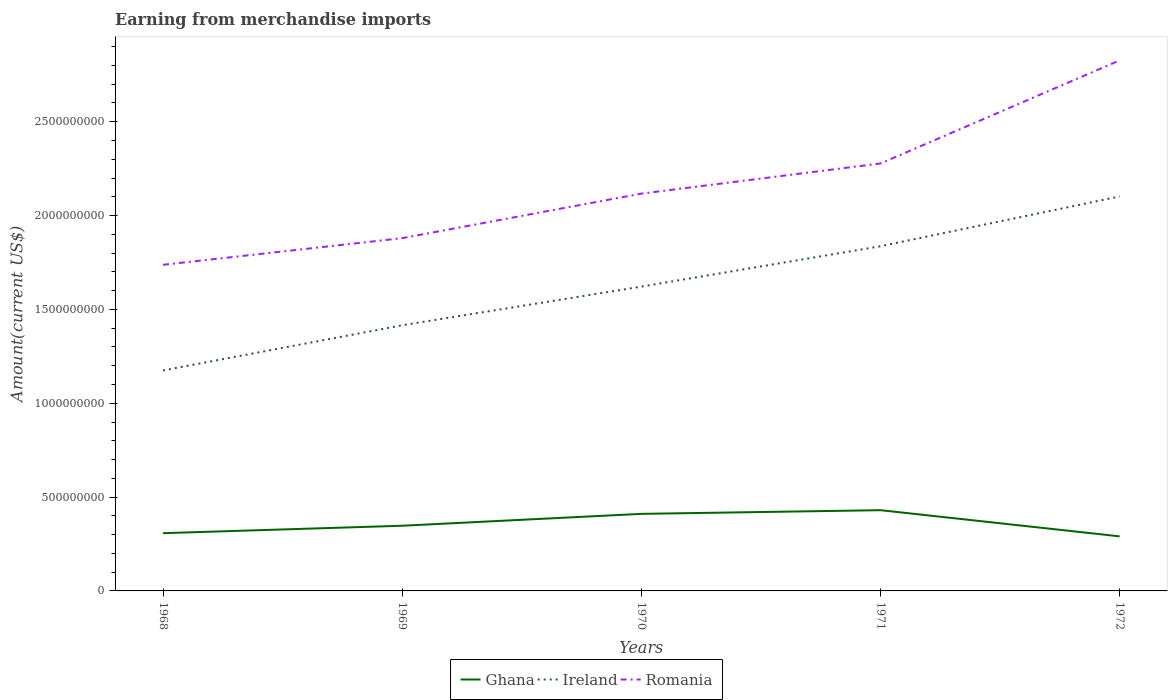Is the number of lines equal to the number of legend labels?
Your response must be concise. Yes. Across all years, what is the maximum amount earned from merchandise imports in Ghana?
Keep it short and to the point. 2.91e+08. In which year was the amount earned from merchandise imports in Romania maximum?
Provide a short and direct response. 1968. What is the total amount earned from merchandise imports in Ghana in the graph?
Offer a very short reply. -3.96e+07. What is the difference between the highest and the second highest amount earned from merchandise imports in Ghana?
Offer a very short reply. 1.39e+08. What is the difference between the highest and the lowest amount earned from merchandise imports in Ghana?
Your answer should be compact. 2. Is the amount earned from merchandise imports in Romania strictly greater than the amount earned from merchandise imports in Ghana over the years?
Ensure brevity in your answer.  No. How many lines are there?
Keep it short and to the point. 3. How many years are there in the graph?
Your answer should be compact. 5. What is the difference between two consecutive major ticks on the Y-axis?
Ensure brevity in your answer.  5.00e+08. Are the values on the major ticks of Y-axis written in scientific E-notation?
Offer a very short reply. No. Does the graph contain any zero values?
Your answer should be very brief. No. Does the graph contain grids?
Provide a succinct answer. No. Where does the legend appear in the graph?
Offer a terse response. Bottom center. How are the legend labels stacked?
Make the answer very short. Horizontal. What is the title of the graph?
Keep it short and to the point. Earning from merchandise imports. Does "Chile" appear as one of the legend labels in the graph?
Offer a terse response. No. What is the label or title of the Y-axis?
Offer a terse response. Amount(current US$). What is the Amount(current US$) in Ghana in 1968?
Your answer should be very brief. 3.08e+08. What is the Amount(current US$) of Ireland in 1968?
Give a very brief answer. 1.17e+09. What is the Amount(current US$) of Romania in 1968?
Your answer should be very brief. 1.74e+09. What is the Amount(current US$) in Ghana in 1969?
Provide a succinct answer. 3.47e+08. What is the Amount(current US$) in Ireland in 1969?
Give a very brief answer. 1.42e+09. What is the Amount(current US$) of Romania in 1969?
Your response must be concise. 1.88e+09. What is the Amount(current US$) of Ghana in 1970?
Your answer should be very brief. 4.11e+08. What is the Amount(current US$) of Ireland in 1970?
Give a very brief answer. 1.62e+09. What is the Amount(current US$) in Romania in 1970?
Ensure brevity in your answer.  2.12e+09. What is the Amount(current US$) of Ghana in 1971?
Your response must be concise. 4.30e+08. What is the Amount(current US$) of Ireland in 1971?
Offer a very short reply. 1.84e+09. What is the Amount(current US$) of Romania in 1971?
Provide a succinct answer. 2.28e+09. What is the Amount(current US$) of Ghana in 1972?
Your answer should be compact. 2.91e+08. What is the Amount(current US$) in Ireland in 1972?
Give a very brief answer. 2.10e+09. What is the Amount(current US$) of Romania in 1972?
Give a very brief answer. 2.83e+09. Across all years, what is the maximum Amount(current US$) of Ghana?
Offer a terse response. 4.30e+08. Across all years, what is the maximum Amount(current US$) in Ireland?
Give a very brief answer. 2.10e+09. Across all years, what is the maximum Amount(current US$) of Romania?
Your answer should be very brief. 2.83e+09. Across all years, what is the minimum Amount(current US$) in Ghana?
Your answer should be compact. 2.91e+08. Across all years, what is the minimum Amount(current US$) of Ireland?
Give a very brief answer. 1.17e+09. Across all years, what is the minimum Amount(current US$) of Romania?
Keep it short and to the point. 1.74e+09. What is the total Amount(current US$) of Ghana in the graph?
Your answer should be compact. 1.79e+09. What is the total Amount(current US$) of Ireland in the graph?
Your answer should be very brief. 8.15e+09. What is the total Amount(current US$) of Romania in the graph?
Offer a very short reply. 1.08e+1. What is the difference between the Amount(current US$) in Ghana in 1968 and that in 1969?
Make the answer very short. -3.96e+07. What is the difference between the Amount(current US$) in Ireland in 1968 and that in 1969?
Provide a succinct answer. -2.41e+08. What is the difference between the Amount(current US$) of Romania in 1968 and that in 1969?
Ensure brevity in your answer.  -1.42e+08. What is the difference between the Amount(current US$) of Ghana in 1968 and that in 1970?
Make the answer very short. -1.03e+08. What is the difference between the Amount(current US$) of Ireland in 1968 and that in 1970?
Keep it short and to the point. -4.47e+08. What is the difference between the Amount(current US$) of Romania in 1968 and that in 1970?
Provide a succinct answer. -3.79e+08. What is the difference between the Amount(current US$) of Ghana in 1968 and that in 1971?
Offer a very short reply. -1.22e+08. What is the difference between the Amount(current US$) in Ireland in 1968 and that in 1971?
Offer a terse response. -6.62e+08. What is the difference between the Amount(current US$) of Romania in 1968 and that in 1971?
Offer a terse response. -5.40e+08. What is the difference between the Amount(current US$) in Ghana in 1968 and that in 1972?
Provide a succinct answer. 1.70e+07. What is the difference between the Amount(current US$) in Ireland in 1968 and that in 1972?
Keep it short and to the point. -9.27e+08. What is the difference between the Amount(current US$) in Romania in 1968 and that in 1972?
Your answer should be very brief. -1.09e+09. What is the difference between the Amount(current US$) of Ghana in 1969 and that in 1970?
Ensure brevity in your answer.  -6.33e+07. What is the difference between the Amount(current US$) of Ireland in 1969 and that in 1970?
Your response must be concise. -2.06e+08. What is the difference between the Amount(current US$) in Romania in 1969 and that in 1970?
Provide a short and direct response. -2.37e+08. What is the difference between the Amount(current US$) in Ghana in 1969 and that in 1971?
Offer a very short reply. -8.29e+07. What is the difference between the Amount(current US$) in Ireland in 1969 and that in 1971?
Your response must be concise. -4.21e+08. What is the difference between the Amount(current US$) in Romania in 1969 and that in 1971?
Your response must be concise. -3.98e+08. What is the difference between the Amount(current US$) of Ghana in 1969 and that in 1972?
Provide a succinct answer. 5.66e+07. What is the difference between the Amount(current US$) in Ireland in 1969 and that in 1972?
Make the answer very short. -6.86e+08. What is the difference between the Amount(current US$) of Romania in 1969 and that in 1972?
Your response must be concise. -9.47e+08. What is the difference between the Amount(current US$) in Ghana in 1970 and that in 1971?
Make the answer very short. -1.96e+07. What is the difference between the Amount(current US$) in Ireland in 1970 and that in 1971?
Give a very brief answer. -2.15e+08. What is the difference between the Amount(current US$) of Romania in 1970 and that in 1971?
Provide a short and direct response. -1.61e+08. What is the difference between the Amount(current US$) in Ghana in 1970 and that in 1972?
Your answer should be very brief. 1.20e+08. What is the difference between the Amount(current US$) in Ireland in 1970 and that in 1972?
Provide a succinct answer. -4.80e+08. What is the difference between the Amount(current US$) in Romania in 1970 and that in 1972?
Provide a succinct answer. -7.10e+08. What is the difference between the Amount(current US$) of Ghana in 1971 and that in 1972?
Make the answer very short. 1.39e+08. What is the difference between the Amount(current US$) in Ireland in 1971 and that in 1972?
Keep it short and to the point. -2.65e+08. What is the difference between the Amount(current US$) of Romania in 1971 and that in 1972?
Your answer should be compact. -5.49e+08. What is the difference between the Amount(current US$) of Ghana in 1968 and the Amount(current US$) of Ireland in 1969?
Provide a succinct answer. -1.11e+09. What is the difference between the Amount(current US$) in Ghana in 1968 and the Amount(current US$) in Romania in 1969?
Your answer should be very brief. -1.57e+09. What is the difference between the Amount(current US$) in Ireland in 1968 and the Amount(current US$) in Romania in 1969?
Your answer should be very brief. -7.05e+08. What is the difference between the Amount(current US$) of Ghana in 1968 and the Amount(current US$) of Ireland in 1970?
Provide a short and direct response. -1.31e+09. What is the difference between the Amount(current US$) in Ghana in 1968 and the Amount(current US$) in Romania in 1970?
Your response must be concise. -1.81e+09. What is the difference between the Amount(current US$) in Ireland in 1968 and the Amount(current US$) in Romania in 1970?
Offer a very short reply. -9.42e+08. What is the difference between the Amount(current US$) of Ghana in 1968 and the Amount(current US$) of Ireland in 1971?
Your answer should be very brief. -1.53e+09. What is the difference between the Amount(current US$) of Ghana in 1968 and the Amount(current US$) of Romania in 1971?
Your answer should be very brief. -1.97e+09. What is the difference between the Amount(current US$) in Ireland in 1968 and the Amount(current US$) in Romania in 1971?
Provide a short and direct response. -1.10e+09. What is the difference between the Amount(current US$) in Ghana in 1968 and the Amount(current US$) in Ireland in 1972?
Your answer should be very brief. -1.79e+09. What is the difference between the Amount(current US$) in Ghana in 1968 and the Amount(current US$) in Romania in 1972?
Ensure brevity in your answer.  -2.52e+09. What is the difference between the Amount(current US$) of Ireland in 1968 and the Amount(current US$) of Romania in 1972?
Offer a terse response. -1.65e+09. What is the difference between the Amount(current US$) of Ghana in 1969 and the Amount(current US$) of Ireland in 1970?
Your response must be concise. -1.27e+09. What is the difference between the Amount(current US$) of Ghana in 1969 and the Amount(current US$) of Romania in 1970?
Your response must be concise. -1.77e+09. What is the difference between the Amount(current US$) in Ireland in 1969 and the Amount(current US$) in Romania in 1970?
Provide a succinct answer. -7.01e+08. What is the difference between the Amount(current US$) of Ghana in 1969 and the Amount(current US$) of Ireland in 1971?
Give a very brief answer. -1.49e+09. What is the difference between the Amount(current US$) in Ghana in 1969 and the Amount(current US$) in Romania in 1971?
Your answer should be compact. -1.93e+09. What is the difference between the Amount(current US$) in Ireland in 1969 and the Amount(current US$) in Romania in 1971?
Give a very brief answer. -8.62e+08. What is the difference between the Amount(current US$) of Ghana in 1969 and the Amount(current US$) of Ireland in 1972?
Ensure brevity in your answer.  -1.75e+09. What is the difference between the Amount(current US$) of Ghana in 1969 and the Amount(current US$) of Romania in 1972?
Your answer should be compact. -2.48e+09. What is the difference between the Amount(current US$) in Ireland in 1969 and the Amount(current US$) in Romania in 1972?
Give a very brief answer. -1.41e+09. What is the difference between the Amount(current US$) of Ghana in 1970 and the Amount(current US$) of Ireland in 1971?
Offer a very short reply. -1.43e+09. What is the difference between the Amount(current US$) of Ghana in 1970 and the Amount(current US$) of Romania in 1971?
Offer a very short reply. -1.87e+09. What is the difference between the Amount(current US$) of Ireland in 1970 and the Amount(current US$) of Romania in 1971?
Give a very brief answer. -6.56e+08. What is the difference between the Amount(current US$) of Ghana in 1970 and the Amount(current US$) of Ireland in 1972?
Offer a terse response. -1.69e+09. What is the difference between the Amount(current US$) of Ghana in 1970 and the Amount(current US$) of Romania in 1972?
Offer a very short reply. -2.42e+09. What is the difference between the Amount(current US$) in Ireland in 1970 and the Amount(current US$) in Romania in 1972?
Your answer should be very brief. -1.21e+09. What is the difference between the Amount(current US$) in Ghana in 1971 and the Amount(current US$) in Ireland in 1972?
Offer a terse response. -1.67e+09. What is the difference between the Amount(current US$) of Ghana in 1971 and the Amount(current US$) of Romania in 1972?
Your answer should be very brief. -2.40e+09. What is the difference between the Amount(current US$) of Ireland in 1971 and the Amount(current US$) of Romania in 1972?
Your answer should be compact. -9.90e+08. What is the average Amount(current US$) of Ghana per year?
Keep it short and to the point. 3.57e+08. What is the average Amount(current US$) in Ireland per year?
Provide a short and direct response. 1.63e+09. What is the average Amount(current US$) in Romania per year?
Make the answer very short. 2.17e+09. In the year 1968, what is the difference between the Amount(current US$) in Ghana and Amount(current US$) in Ireland?
Give a very brief answer. -8.67e+08. In the year 1968, what is the difference between the Amount(current US$) of Ghana and Amount(current US$) of Romania?
Offer a very short reply. -1.43e+09. In the year 1968, what is the difference between the Amount(current US$) in Ireland and Amount(current US$) in Romania?
Your answer should be compact. -5.63e+08. In the year 1969, what is the difference between the Amount(current US$) of Ghana and Amount(current US$) of Ireland?
Give a very brief answer. -1.07e+09. In the year 1969, what is the difference between the Amount(current US$) in Ghana and Amount(current US$) in Romania?
Offer a very short reply. -1.53e+09. In the year 1969, what is the difference between the Amount(current US$) in Ireland and Amount(current US$) in Romania?
Ensure brevity in your answer.  -4.64e+08. In the year 1970, what is the difference between the Amount(current US$) in Ghana and Amount(current US$) in Ireland?
Give a very brief answer. -1.21e+09. In the year 1970, what is the difference between the Amount(current US$) in Ghana and Amount(current US$) in Romania?
Provide a short and direct response. -1.71e+09. In the year 1970, what is the difference between the Amount(current US$) of Ireland and Amount(current US$) of Romania?
Offer a very short reply. -4.96e+08. In the year 1971, what is the difference between the Amount(current US$) of Ghana and Amount(current US$) of Ireland?
Offer a very short reply. -1.41e+09. In the year 1971, what is the difference between the Amount(current US$) of Ghana and Amount(current US$) of Romania?
Offer a terse response. -1.85e+09. In the year 1971, what is the difference between the Amount(current US$) in Ireland and Amount(current US$) in Romania?
Give a very brief answer. -4.41e+08. In the year 1972, what is the difference between the Amount(current US$) in Ghana and Amount(current US$) in Ireland?
Keep it short and to the point. -1.81e+09. In the year 1972, what is the difference between the Amount(current US$) in Ghana and Amount(current US$) in Romania?
Keep it short and to the point. -2.54e+09. In the year 1972, what is the difference between the Amount(current US$) of Ireland and Amount(current US$) of Romania?
Your answer should be very brief. -7.25e+08. What is the ratio of the Amount(current US$) of Ghana in 1968 to that in 1969?
Offer a terse response. 0.89. What is the ratio of the Amount(current US$) in Ireland in 1968 to that in 1969?
Make the answer very short. 0.83. What is the ratio of the Amount(current US$) in Romania in 1968 to that in 1969?
Your response must be concise. 0.92. What is the ratio of the Amount(current US$) in Ghana in 1968 to that in 1970?
Give a very brief answer. 0.75. What is the ratio of the Amount(current US$) of Ireland in 1968 to that in 1970?
Your answer should be compact. 0.72. What is the ratio of the Amount(current US$) in Romania in 1968 to that in 1970?
Provide a succinct answer. 0.82. What is the ratio of the Amount(current US$) in Ghana in 1968 to that in 1971?
Provide a short and direct response. 0.72. What is the ratio of the Amount(current US$) of Ireland in 1968 to that in 1971?
Ensure brevity in your answer.  0.64. What is the ratio of the Amount(current US$) of Romania in 1968 to that in 1971?
Keep it short and to the point. 0.76. What is the ratio of the Amount(current US$) of Ghana in 1968 to that in 1972?
Your response must be concise. 1.06. What is the ratio of the Amount(current US$) of Ireland in 1968 to that in 1972?
Your answer should be very brief. 0.56. What is the ratio of the Amount(current US$) in Romania in 1968 to that in 1972?
Provide a succinct answer. 0.61. What is the ratio of the Amount(current US$) in Ghana in 1969 to that in 1970?
Your answer should be very brief. 0.85. What is the ratio of the Amount(current US$) of Ireland in 1969 to that in 1970?
Offer a terse response. 0.87. What is the ratio of the Amount(current US$) of Romania in 1969 to that in 1970?
Offer a very short reply. 0.89. What is the ratio of the Amount(current US$) in Ghana in 1969 to that in 1971?
Keep it short and to the point. 0.81. What is the ratio of the Amount(current US$) of Ireland in 1969 to that in 1971?
Provide a short and direct response. 0.77. What is the ratio of the Amount(current US$) of Romania in 1969 to that in 1971?
Make the answer very short. 0.83. What is the ratio of the Amount(current US$) of Ghana in 1969 to that in 1972?
Keep it short and to the point. 1.19. What is the ratio of the Amount(current US$) of Ireland in 1969 to that in 1972?
Provide a short and direct response. 0.67. What is the ratio of the Amount(current US$) in Romania in 1969 to that in 1972?
Offer a very short reply. 0.66. What is the ratio of the Amount(current US$) of Ghana in 1970 to that in 1971?
Provide a succinct answer. 0.95. What is the ratio of the Amount(current US$) of Ireland in 1970 to that in 1971?
Offer a terse response. 0.88. What is the ratio of the Amount(current US$) in Romania in 1970 to that in 1971?
Offer a terse response. 0.93. What is the ratio of the Amount(current US$) in Ghana in 1970 to that in 1972?
Make the answer very short. 1.41. What is the ratio of the Amount(current US$) of Ireland in 1970 to that in 1972?
Make the answer very short. 0.77. What is the ratio of the Amount(current US$) in Romania in 1970 to that in 1972?
Offer a very short reply. 0.75. What is the ratio of the Amount(current US$) of Ghana in 1971 to that in 1972?
Ensure brevity in your answer.  1.48. What is the ratio of the Amount(current US$) in Ireland in 1971 to that in 1972?
Make the answer very short. 0.87. What is the ratio of the Amount(current US$) in Romania in 1971 to that in 1972?
Your answer should be very brief. 0.81. What is the difference between the highest and the second highest Amount(current US$) in Ghana?
Make the answer very short. 1.96e+07. What is the difference between the highest and the second highest Amount(current US$) in Ireland?
Offer a very short reply. 2.65e+08. What is the difference between the highest and the second highest Amount(current US$) of Romania?
Provide a succinct answer. 5.49e+08. What is the difference between the highest and the lowest Amount(current US$) of Ghana?
Provide a short and direct response. 1.39e+08. What is the difference between the highest and the lowest Amount(current US$) in Ireland?
Give a very brief answer. 9.27e+08. What is the difference between the highest and the lowest Amount(current US$) of Romania?
Offer a terse response. 1.09e+09. 